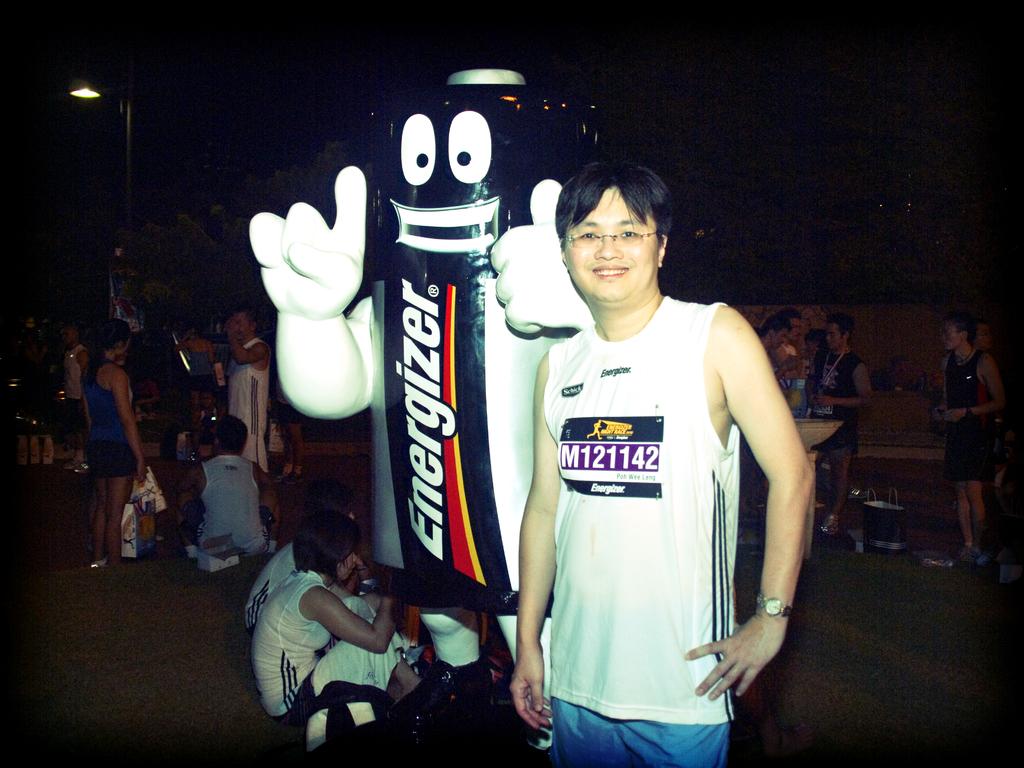What type of battery is this?
Your answer should be compact. Energizer. What is the number on the shirt?
Provide a succinct answer. M121142. 